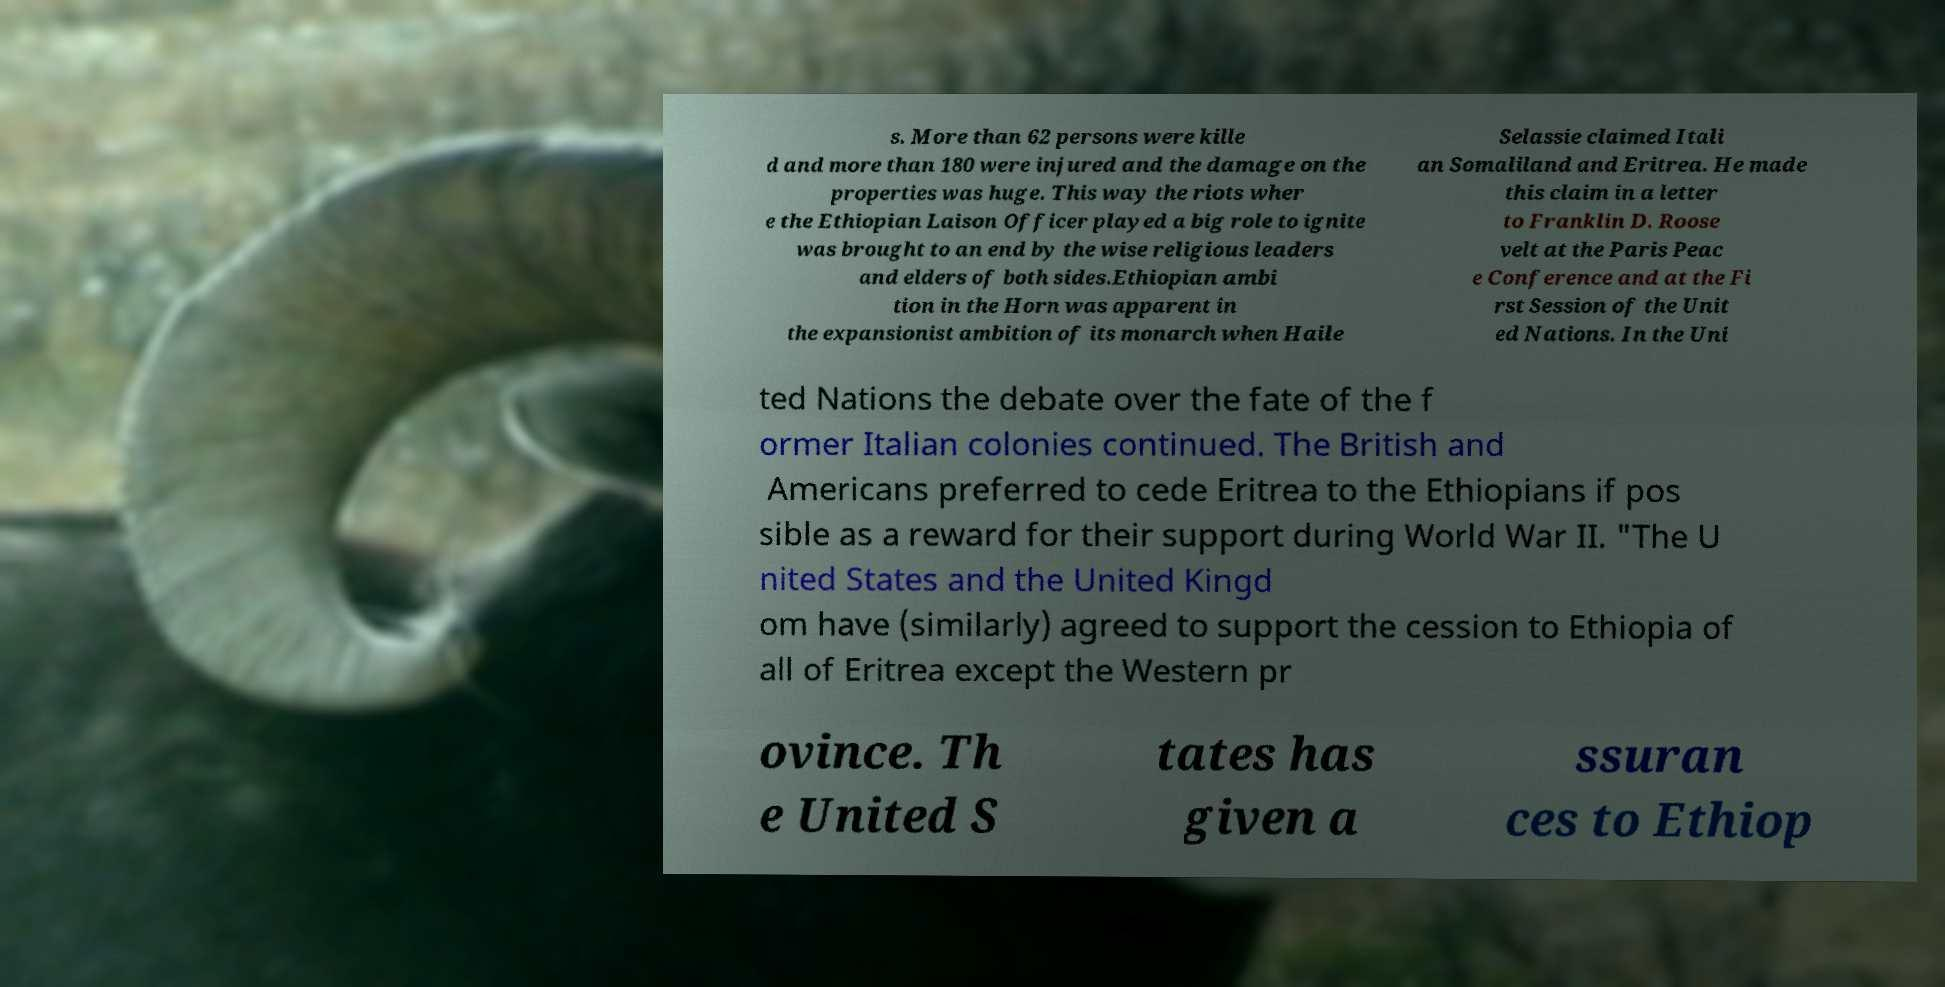Please identify and transcribe the text found in this image. s. More than 62 persons were kille d and more than 180 were injured and the damage on the properties was huge. This way the riots wher e the Ethiopian Laison Officer played a big role to ignite was brought to an end by the wise religious leaders and elders of both sides.Ethiopian ambi tion in the Horn was apparent in the expansionist ambition of its monarch when Haile Selassie claimed Itali an Somaliland and Eritrea. He made this claim in a letter to Franklin D. Roose velt at the Paris Peac e Conference and at the Fi rst Session of the Unit ed Nations. In the Uni ted Nations the debate over the fate of the f ormer Italian colonies continued. The British and Americans preferred to cede Eritrea to the Ethiopians if pos sible as a reward for their support during World War II. "The U nited States and the United Kingd om have (similarly) agreed to support the cession to Ethiopia of all of Eritrea except the Western pr ovince. Th e United S tates has given a ssuran ces to Ethiop 